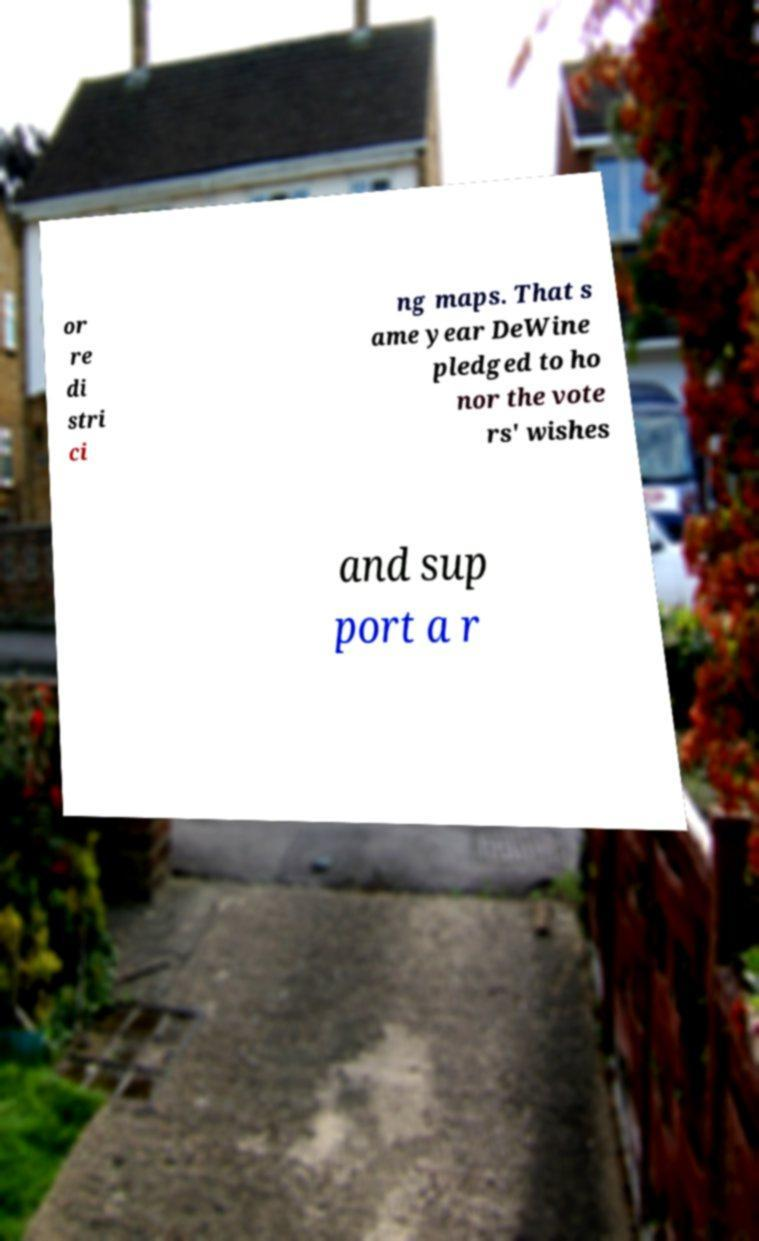Could you assist in decoding the text presented in this image and type it out clearly? or re di stri ci ng maps. That s ame year DeWine pledged to ho nor the vote rs' wishes and sup port a r 